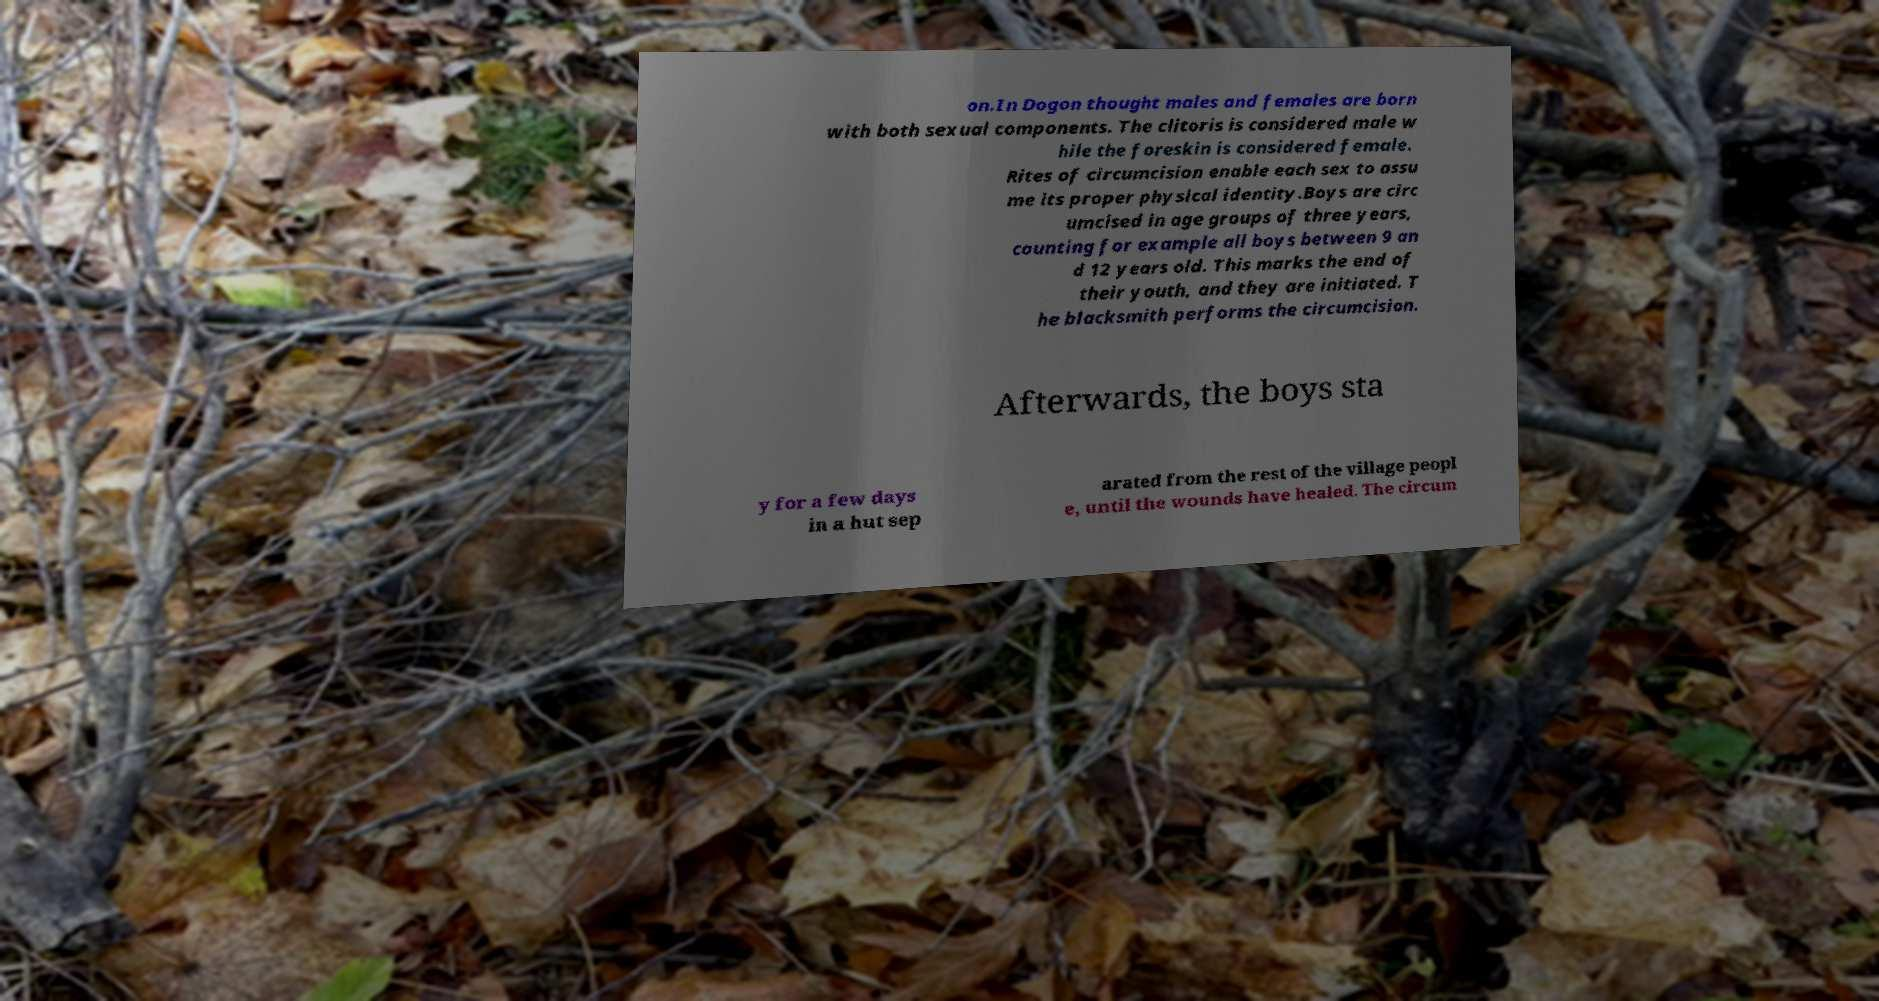Can you read and provide the text displayed in the image?This photo seems to have some interesting text. Can you extract and type it out for me? on.In Dogon thought males and females are born with both sexual components. The clitoris is considered male w hile the foreskin is considered female. Rites of circumcision enable each sex to assu me its proper physical identity.Boys are circ umcised in age groups of three years, counting for example all boys between 9 an d 12 years old. This marks the end of their youth, and they are initiated. T he blacksmith performs the circumcision. Afterwards, the boys sta y for a few days in a hut sep arated from the rest of the village peopl e, until the wounds have healed. The circum 